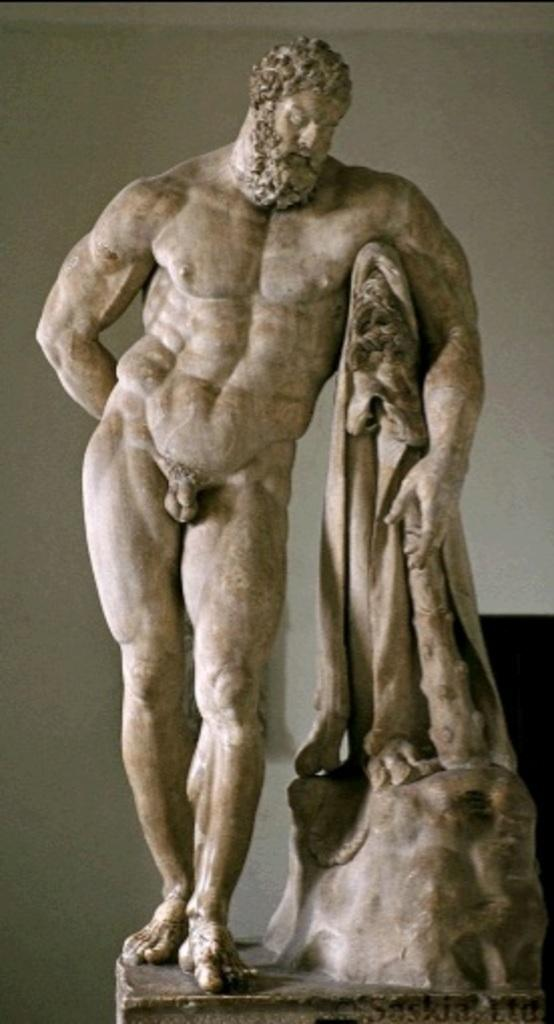What is located on the left side of the image? There is a statue of a nude person on the left side of the image. What is the statue holding? The statue is holding an object. Where is the statue positioned in the image? The statue is on a platform. What can be seen in the background of the image? There is a white wall in the background of the image. What type of crime is being committed in the image? There is no crime being committed in the image; it features a statue on a platform. What type of popcorn is being served at the vacation spot in the image? There is no vacation spot or popcorn present in the image; it features a statue on a platform in front of a white wall. 